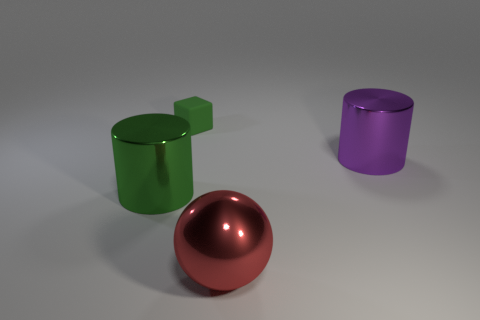There is a large object to the left of the large red thing; does it have the same shape as the purple metallic thing?
Ensure brevity in your answer.  Yes. Are there fewer large green cylinders than large gray spheres?
Provide a succinct answer. No. There is a ball that is the same size as the purple metal cylinder; what is it made of?
Offer a terse response. Metal. There is a small rubber object; is its color the same as the thing that is on the left side of the small object?
Offer a terse response. Yes. Is the number of large balls that are behind the block less than the number of large green matte objects?
Offer a very short reply. No. What number of gray spheres are there?
Offer a terse response. 0. There is a green matte thing that is right of the big cylinder that is to the left of the purple shiny cylinder; what is its shape?
Keep it short and to the point. Cube. There is a purple object; how many red spheres are in front of it?
Offer a very short reply. 1. Does the ball have the same material as the small green cube on the left side of the large red object?
Give a very brief answer. No. Is there a green shiny object that has the same size as the green cube?
Make the answer very short. No. 